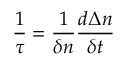<formula> <loc_0><loc_0><loc_500><loc_500>\frac { 1 } { \tau } = \frac { 1 } { \delta n } \frac { d \Delta n } { \delta t }</formula> 